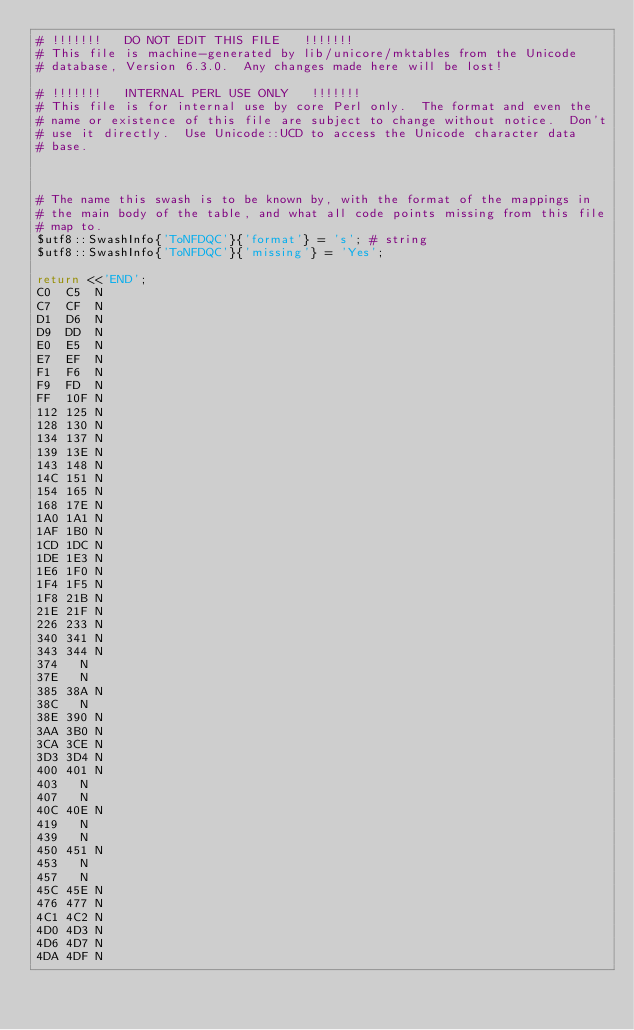Convert code to text. <code><loc_0><loc_0><loc_500><loc_500><_Perl_># !!!!!!!   DO NOT EDIT THIS FILE   !!!!!!!
# This file is machine-generated by lib/unicore/mktables from the Unicode
# database, Version 6.3.0.  Any changes made here will be lost!

# !!!!!!!   INTERNAL PERL USE ONLY   !!!!!!!
# This file is for internal use by core Perl only.  The format and even the
# name or existence of this file are subject to change without notice.  Don't
# use it directly.  Use Unicode::UCD to access the Unicode character data
# base.



# The name this swash is to be known by, with the format of the mappings in
# the main body of the table, and what all code points missing from this file
# map to.
$utf8::SwashInfo{'ToNFDQC'}{'format'} = 's'; # string
$utf8::SwashInfo{'ToNFDQC'}{'missing'} = 'Yes';

return <<'END';
C0	C5	N
C7	CF	N
D1	D6	N
D9	DD	N
E0	E5	N
E7	EF	N
F1	F6	N
F9	FD	N
FF	10F	N
112	125	N
128	130	N
134	137	N
139	13E	N
143	148	N
14C	151	N
154	165	N
168	17E	N
1A0	1A1	N
1AF	1B0	N
1CD	1DC	N
1DE	1E3	N
1E6	1F0	N
1F4	1F5	N
1F8	21B	N
21E	21F	N
226	233	N
340	341	N
343	344	N
374		N
37E		N
385	38A	N
38C		N
38E	390	N
3AA	3B0	N
3CA	3CE	N
3D3	3D4	N
400	401	N
403		N
407		N
40C	40E	N
419		N
439		N
450	451	N
453		N
457		N
45C	45E	N
476	477	N
4C1	4C2	N
4D0	4D3	N
4D6	4D7	N
4DA	4DF	N</code> 